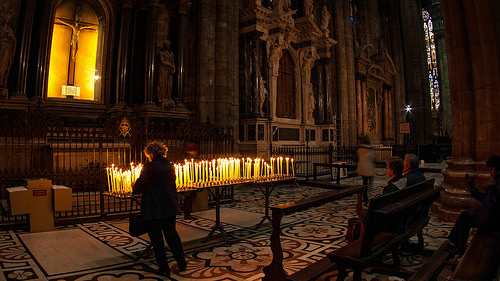<image>
Can you confirm if the candle is in front of the idol? Yes. The candle is positioned in front of the idol, appearing closer to the camera viewpoint. 